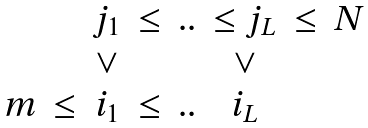Convert formula to latex. <formula><loc_0><loc_0><loc_500><loc_500>\begin{matrix} & & j _ { 1 } & \leq & . . & \leq j _ { L } & \leq & N \\ & & \lor & & & \lor \\ m & \leq & i _ { 1 } & \leq & . . & i _ { L } & \end{matrix}</formula> 